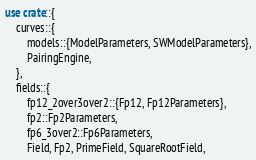Convert code to text. <code><loc_0><loc_0><loc_500><loc_500><_Rust_>use crate::{
    curves::{
        models::{ModelParameters, SWModelParameters},
        PairingEngine,
    },
    fields::{
        fp12_2over3over2::{Fp12, Fp12Parameters},
        fp2::Fp2Parameters,
        fp6_3over2::Fp6Parameters,
        Field, Fp2, PrimeField, SquareRootField,</code> 